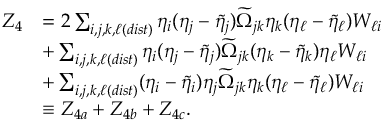Convert formula to latex. <formula><loc_0><loc_0><loc_500><loc_500>\begin{array} { r l } { Z _ { 4 } } & { = 2 \sum _ { i , j , k , \ell ( d i s t ) } \eta _ { i } ( \eta _ { j } - \tilde { \eta } _ { j } ) \widetilde { \Omega } _ { j k } \eta _ { k } ( \eta _ { \ell } - \tilde { \eta } _ { \ell } ) W _ { \ell i } } \\ & { + \sum _ { i , j , k , \ell ( d i s t ) } \eta _ { i } ( \eta _ { j } - \tilde { \eta } _ { j } ) \widetilde { \Omega } _ { j k } ( \eta _ { k } - \tilde { \eta } _ { k } ) \eta _ { \ell } W _ { \ell i } } \\ & { + \sum _ { i , j , k , \ell ( d i s t ) } ( \eta _ { i } - \tilde { \eta } _ { i } ) \eta _ { j } \widetilde { \Omega } _ { j k } \eta _ { k } ( \eta _ { \ell } - \tilde { \eta } _ { \ell } ) W _ { \ell i } } \\ & { \equiv Z _ { 4 a } + Z _ { 4 b } + Z _ { 4 c } . } \end{array}</formula> 